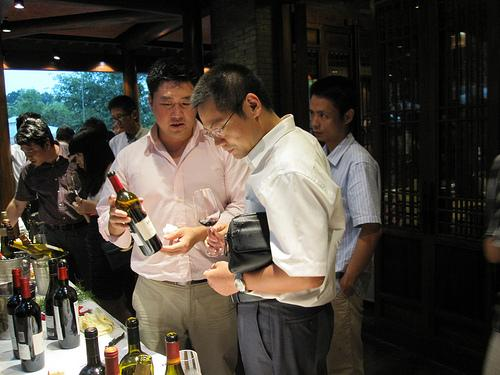Provide a brief description of the group of Asian people in the picture. The group of Asian people consists of a man wearing a pink shirt and glasses, a man wearing tan pants, and a woman holding a wine glass. What can be found on the table in the image? There are various wine bottles, ice buckets, a silver wine bucket, and a wine bottle inside a metal bucket on the table. Describe the setting of the image in terms of lighting and location. The setting is a bar with low lighting, and the view from the window shows another part of the bar. List the clothing items and accessories worn by the young male in a blue shirt. The young male is wearing a blue shirt and khaki pants. No specific accessories are mentioned for him. Which item related to wine consumption is nearly empty in the image? There is a nearly empty wine glass in the image. What type of apparel is the man with glasses wearing, and what additional accessory is he wearing? The man with glasses is wearing a short-sleeved pink shirt and tan pants, and he has a wristwatch with a black band on his left wrist. State two different activities taking place among the people in the image. Two activities include a man looking at a wine bottle and two Asian men talking to each other. What color shirts do the two people talking in the image wear? One person is wearing a pink shirt, and the other person is wearing a white shirt. Identify the action performed by the man holding a wine bottle in the image. The man is holding a wine bottle and possibly examining it, as he has a thoughtful look on his face. Describe the wine glass held by the Asian woman in the image. The Asian woman is holding a wine glass, but no further details about the glass are mentioned. 